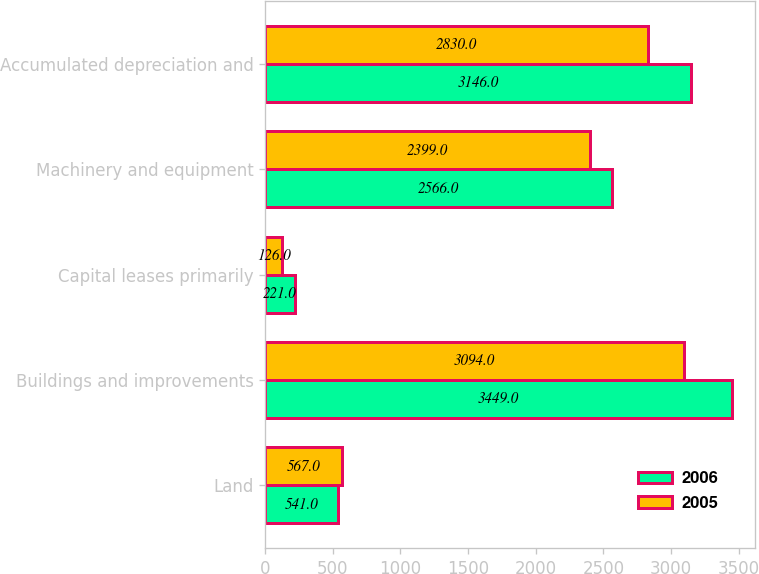<chart> <loc_0><loc_0><loc_500><loc_500><stacked_bar_chart><ecel><fcel>Land<fcel>Buildings and improvements<fcel>Capital leases primarily<fcel>Machinery and equipment<fcel>Accumulated depreciation and<nl><fcel>2006<fcel>541<fcel>3449<fcel>221<fcel>2566<fcel>3146<nl><fcel>2005<fcel>567<fcel>3094<fcel>126<fcel>2399<fcel>2830<nl></chart> 